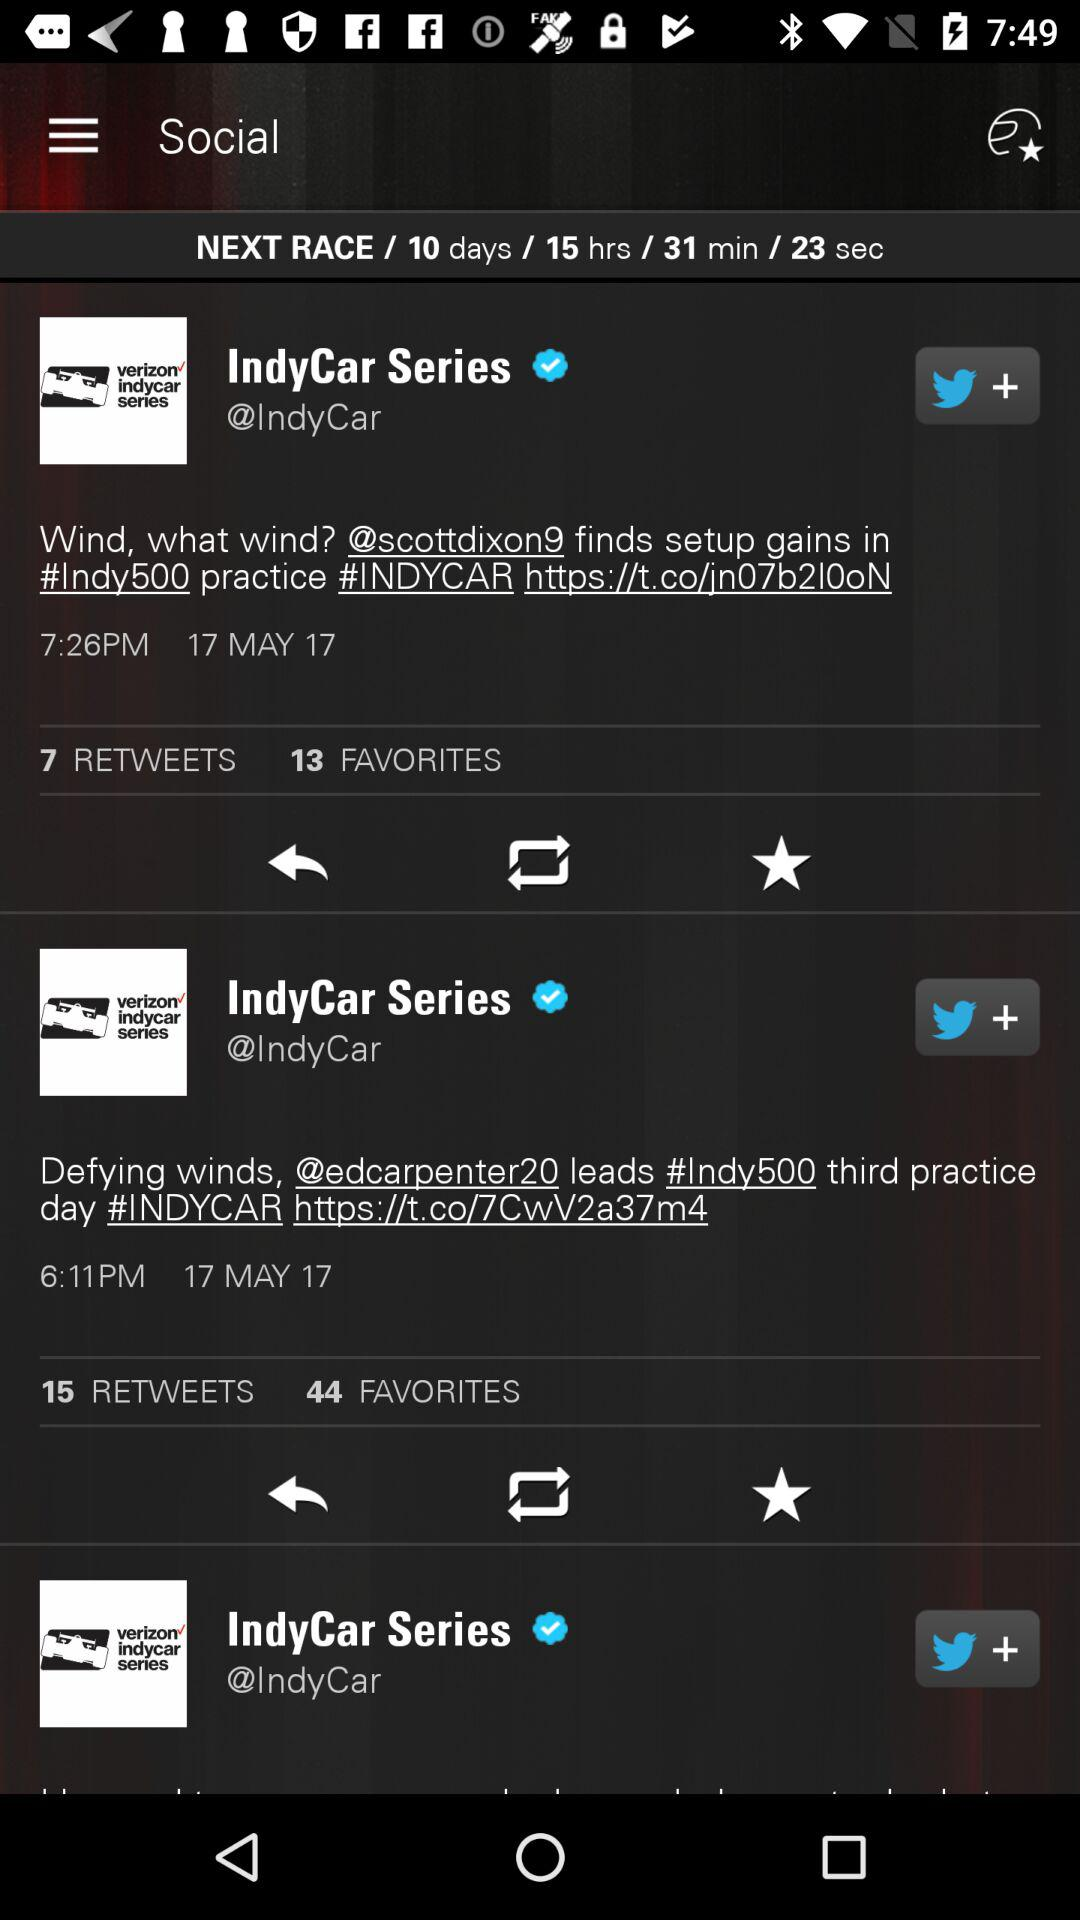When will the next race be? The next race will be in 10 days, 15 hours, 31 minutes and 23 seconds. 